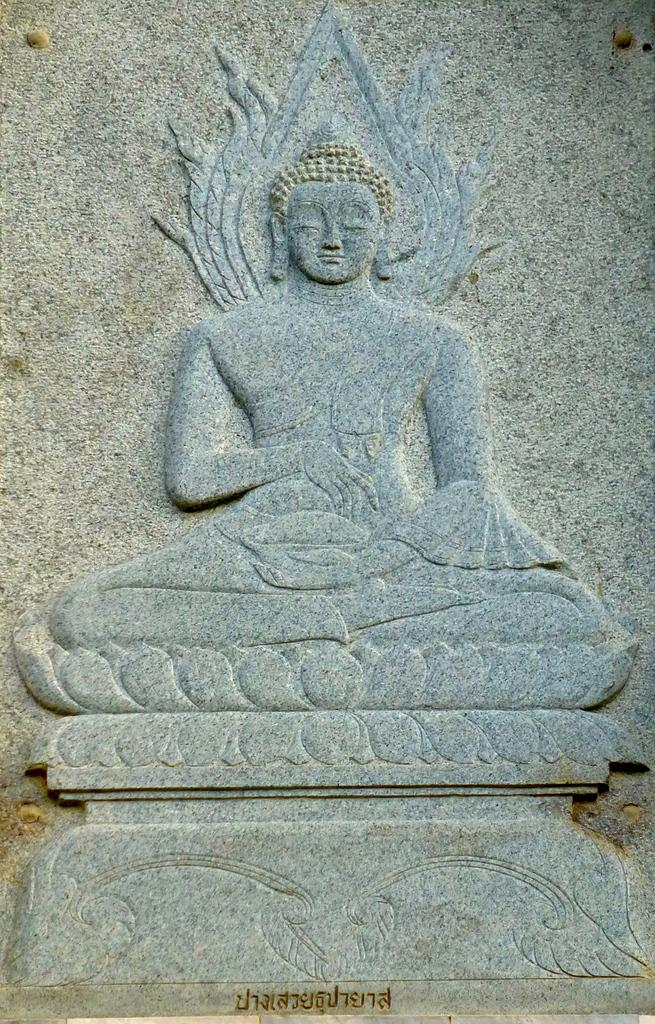What is the main subject of the image? There is a statue of a person in the image. What is the statue standing on? The statue is on a granite stone. Is there any text or writing in the image? Yes, there is writing on the stone at the bottom of the statue. How many pairs of shoes are visible in the image? There are no shoes visible in the image, as it features a statue on a granite stone with writing on the stone. What is the amount of pigs present in the image? There are no pigs present in the image; it features a statue of a person on a granite stone with writing on the stone. 